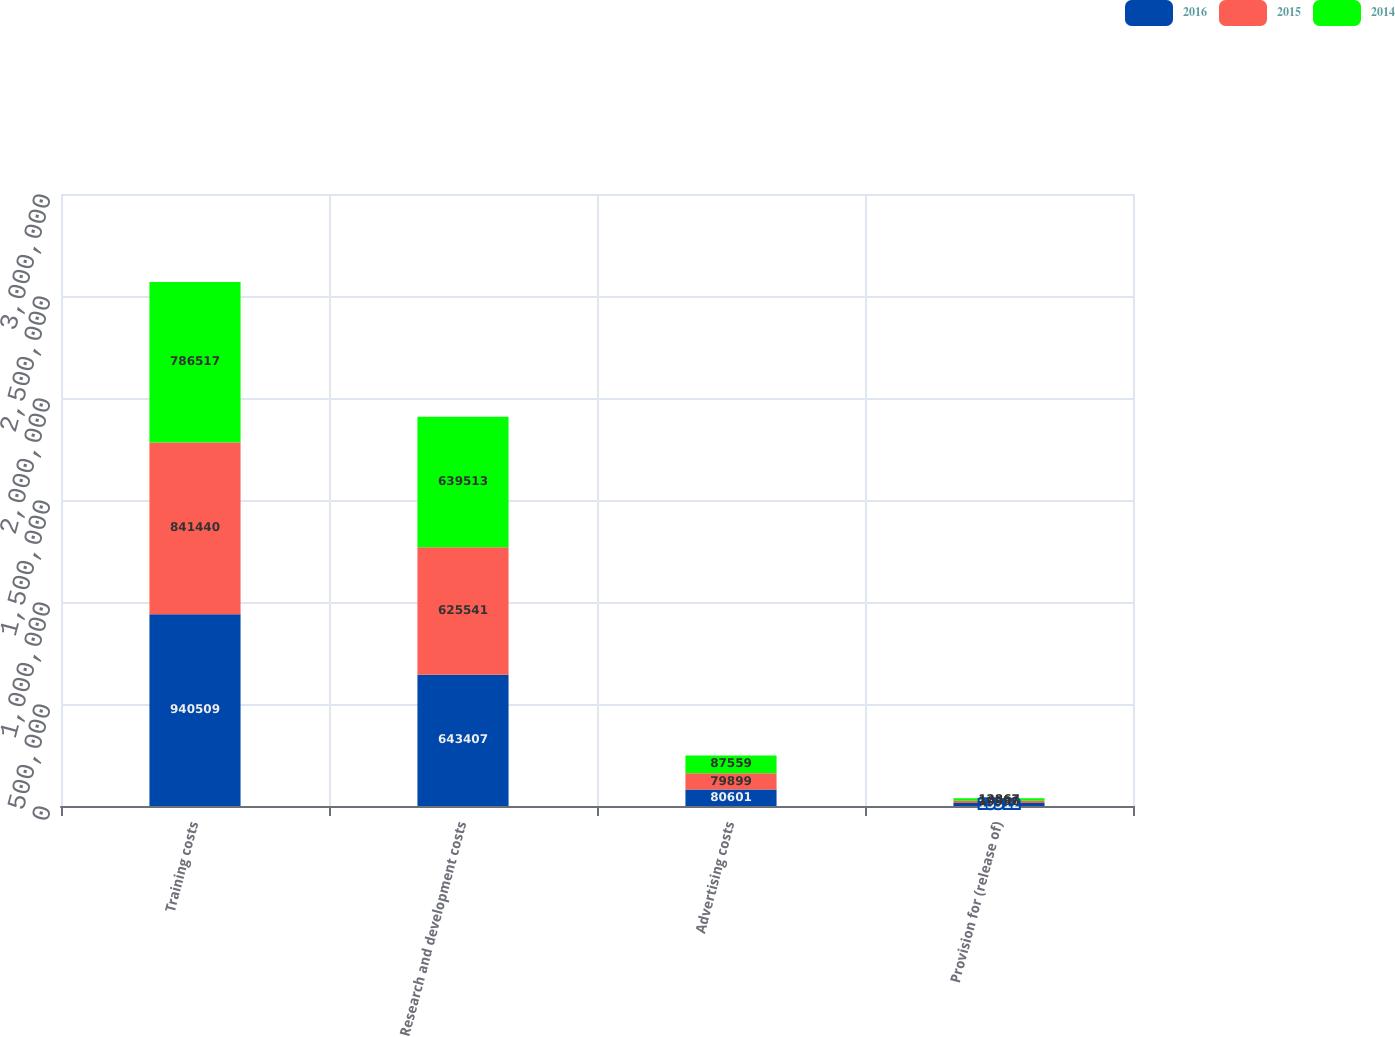Convert chart. <chart><loc_0><loc_0><loc_500><loc_500><stacked_bar_chart><ecel><fcel>Training costs<fcel>Research and development costs<fcel>Advertising costs<fcel>Provision for (release of)<nl><fcel>2016<fcel>940509<fcel>643407<fcel>80601<fcel>15312<nl><fcel>2015<fcel>841440<fcel>625541<fcel>79899<fcel>10336<nl><fcel>2014<fcel>786517<fcel>639513<fcel>87559<fcel>12867<nl></chart> 